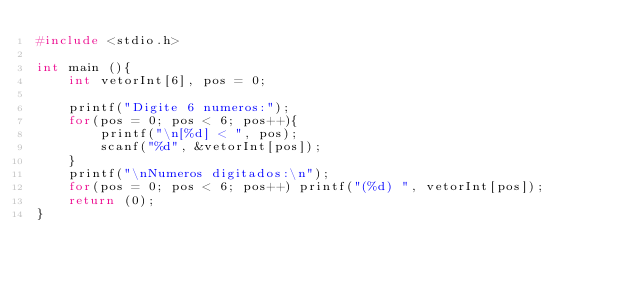Convert code to text. <code><loc_0><loc_0><loc_500><loc_500><_C_>#include <stdio.h>

int main (){
	int vetorInt[6], pos = 0;
	
	printf("Digite 6 numeros:");
	for(pos = 0; pos < 6; pos++){
		printf("\n[%d] < ", pos);
		scanf("%d", &vetorInt[pos]);
	}
	printf("\nNumeros digitados:\n");
	for(pos = 0; pos < 6; pos++) printf("(%d) ", vetorInt[pos]);
	return (0);
}
</code> 